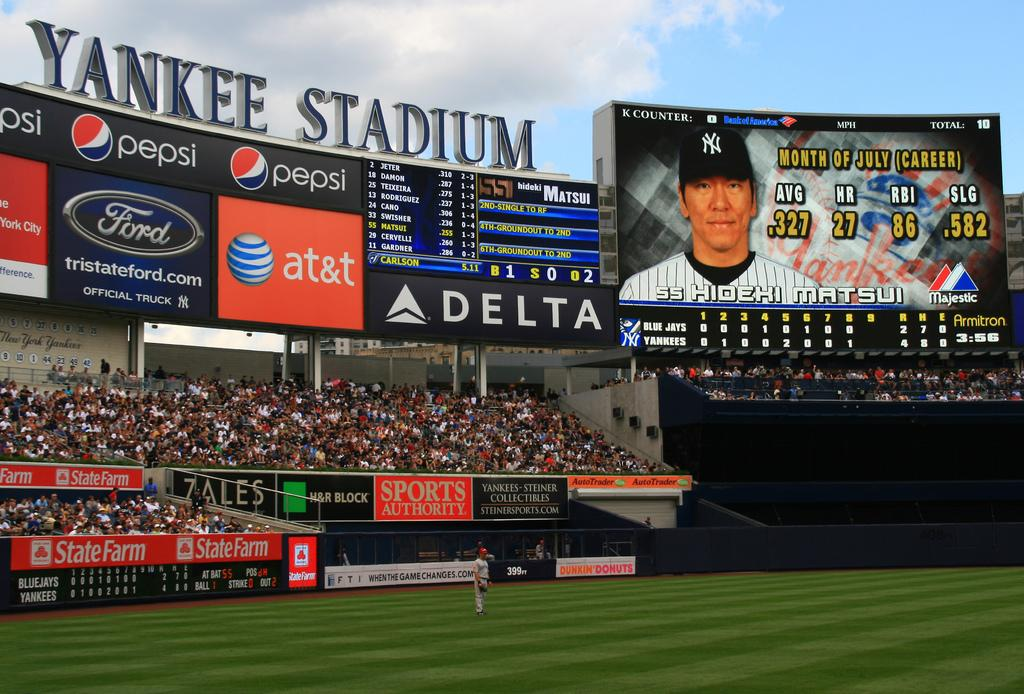<image>
Create a compact narrative representing the image presented. Hideki Matsui's picture and statistics are on the scoreboard at Yankee Stadium. 